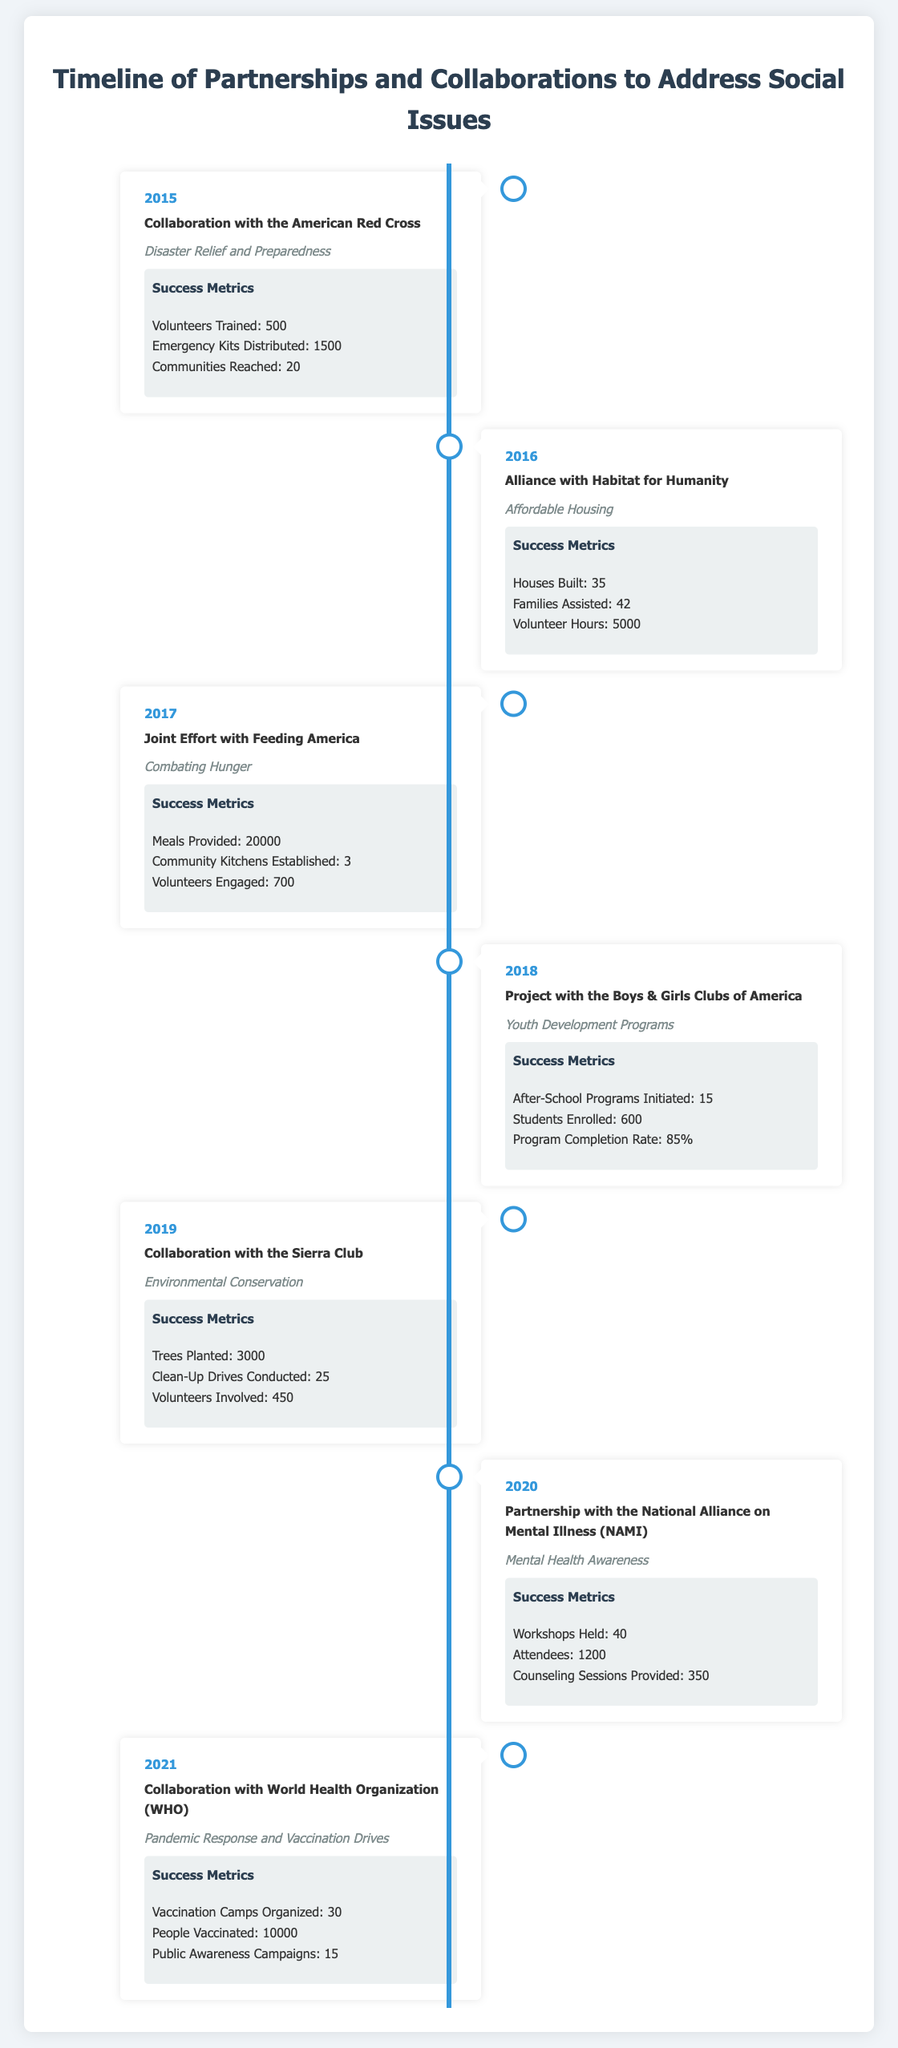What year did the collaboration with the American Red Cross occur? The document specifies that the collaboration occurred in 2015.
Answer: 2015 How many meals were provided through the joint effort with Feeding America? The document states that 20,000 meals were provided in the effort.
Answer: 20000 What was the focus of the partnership with Habitat for Humanity? The document indicates that the focus was on affordable housing.
Answer: Affordable Housing How many trees were planted in the collaboration with the Sierra Club? The document specifies that 3,000 trees were planted in this initiative.
Answer: 3000 Which organization was involved in mental health awareness in 2020? The document reveals that the partnership was with the National Alliance on Mental Illness (NAMI).
Answer: National Alliance on Mental Illness (NAMI) What was the total number of attendees in the mental health workshops held? According to the document, there were 1,200 attendees at the workshops.
Answer: 1200 In what year did the collaboration with World Health Organization aim at pandemic response? The document shows that this collaboration occurred in 2021.
Answer: 2021 How many families were assisted during the partnership with Habitat for Humanity? The document states that 42 families were assisted in this endeavor.
Answer: 42 What was the program completion rate for the youth development programs in 2018? The document indicates that the program completion rate was 85%.
Answer: 85% 